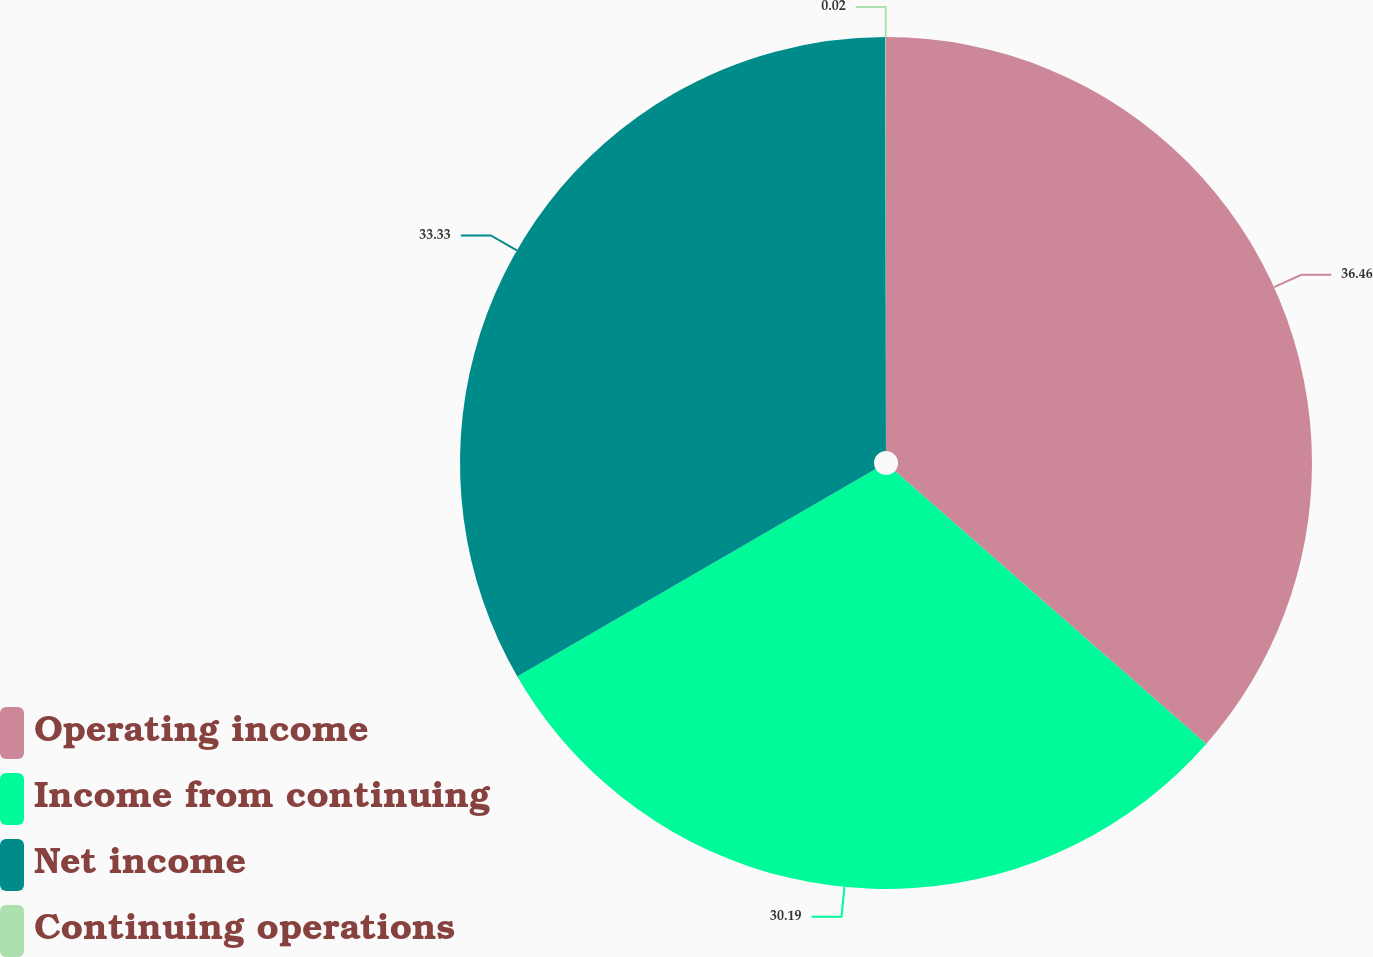<chart> <loc_0><loc_0><loc_500><loc_500><pie_chart><fcel>Operating income<fcel>Income from continuing<fcel>Net income<fcel>Continuing operations<nl><fcel>36.46%<fcel>30.19%<fcel>33.33%<fcel>0.02%<nl></chart> 